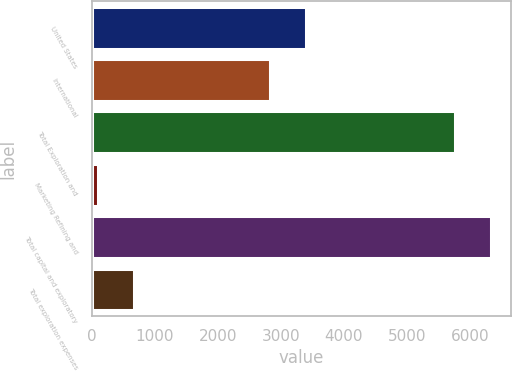<chart> <loc_0><loc_0><loc_500><loc_500><bar_chart><fcel>United States<fcel>International<fcel>Total Exploration and<fcel>Marketing Refining and<fcel>Total capital and exploratory<fcel>Total exploration expenses<nl><fcel>3397.7<fcel>2822<fcel>5757<fcel>98<fcel>6332.7<fcel>673.7<nl></chart> 